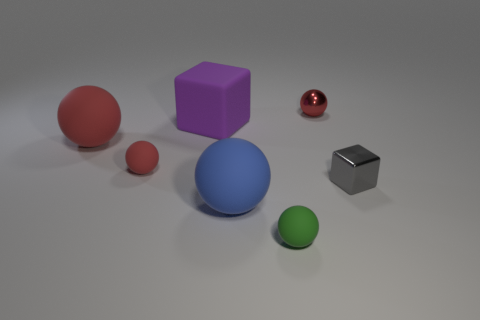How many red balls must be subtracted to get 1 red balls? 2 Subtract all brown cubes. How many red balls are left? 3 Subtract all green spheres. How many spheres are left? 4 Subtract all blue balls. How many balls are left? 4 Subtract all yellow balls. Subtract all blue cylinders. How many balls are left? 5 Add 1 gray metal blocks. How many objects exist? 8 Subtract all blocks. How many objects are left? 5 Subtract all large red objects. Subtract all large matte blocks. How many objects are left? 5 Add 7 tiny spheres. How many tiny spheres are left? 10 Add 2 yellow shiny blocks. How many yellow shiny blocks exist? 2 